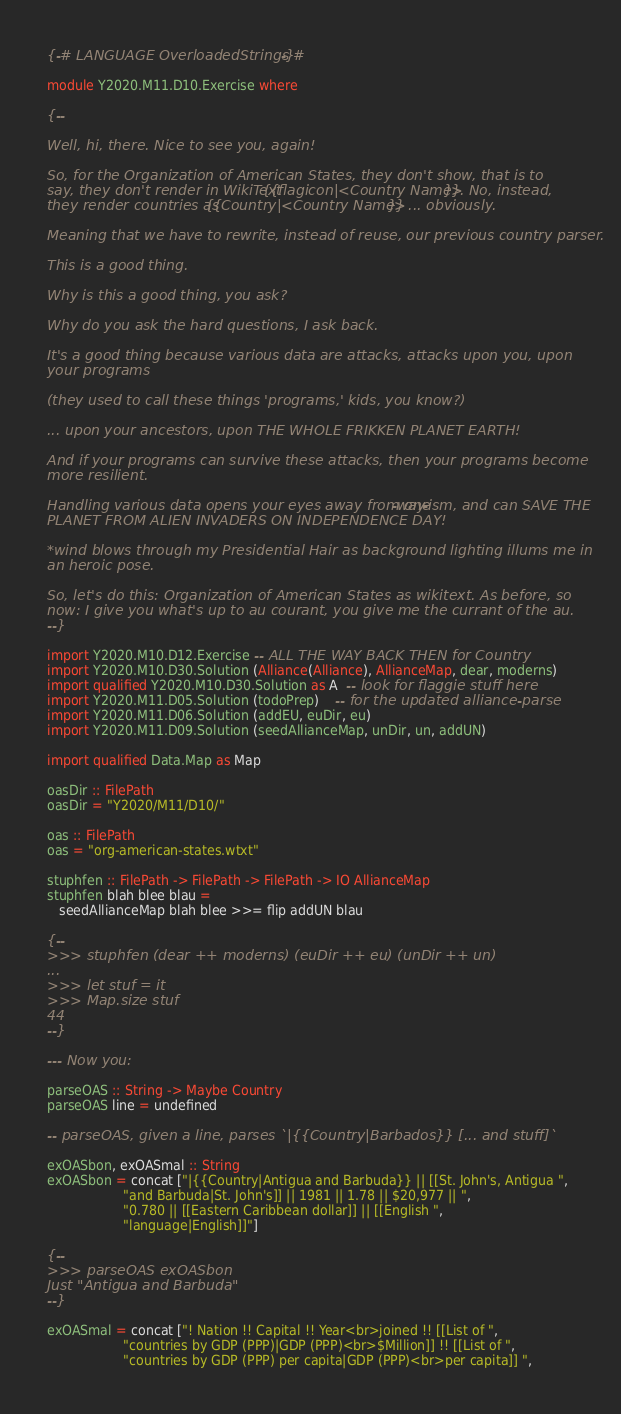Convert code to text. <code><loc_0><loc_0><loc_500><loc_500><_Haskell_>{-# LANGUAGE OverloadedStrings #-}

module Y2020.M11.D10.Exercise where

{--

Well, hi, there. Nice to see you, again!

So, for the Organization of American States, they don't show, that is to
say, they don't render in WikiText {{flagicon|<Country Name>}}. No, instead,
they render countries as {{Country|<Country Name>}} ... obviously.

Meaning that we have to rewrite, instead of reuse, our previous country parser.

This is a good thing.

Why is this a good thing, you ask?

Why do you ask the hard questions, I ask back.

It's a good thing because various data are attacks, attacks upon you, upon
your programs

(they used to call these things 'programs,' kids, you know?)

... upon your ancestors, upon THE WHOLE FRIKKEN PLANET EARTH!

And if your programs can survive these attacks, then your programs become
more resilient.

Handling various data opens your eyes away from one-way-ism, and can SAVE THE
PLANET FROM ALIEN INVADERS ON INDEPENDENCE DAY!

*wind blows through my Presidential Hair as background lighting illums me in
an heroic pose.

So, let's do this: Organization of American States as wikitext. As before, so
now: I give you what's up to au courant, you give me the currant of the au.
--}

import Y2020.M10.D12.Exercise -- ALL THE WAY BACK THEN for Country
import Y2020.M10.D30.Solution (Alliance(Alliance), AllianceMap, dear, moderns)
import qualified Y2020.M10.D30.Solution as A  -- look for flaggie stuff here
import Y2020.M11.D05.Solution (todoPrep)    -- for the updated alliance-parse
import Y2020.M11.D06.Solution (addEU, euDir, eu)
import Y2020.M11.D09.Solution (seedAllianceMap, unDir, un, addUN)

import qualified Data.Map as Map

oasDir :: FilePath
oasDir = "Y2020/M11/D10/"

oas :: FilePath
oas = "org-american-states.wtxt"

stuphfen :: FilePath -> FilePath -> FilePath -> IO AllianceMap
stuphfen blah blee blau =
   seedAllianceMap blah blee >>= flip addUN blau

{--
>>> stuphfen (dear ++ moderns) (euDir ++ eu) (unDir ++ un)
...
>>> let stuf = it
>>> Map.size stuf
44
--}

--- Now you:

parseOAS :: String -> Maybe Country
parseOAS line = undefined

-- parseOAS, given a line, parses `|{{Country|Barbados}} [... and stuff]`

exOASbon, exOASmal :: String
exOASbon = concat ["|{{Country|Antigua and Barbuda}} || [[St. John's, Antigua ",
                   "and Barbuda|St. John's]] || 1981 || 1.78 || $20,977 || ",
                   "0.780 || [[Eastern Caribbean dollar]] || [[English ",
                   "language|English]]"]

{--
>>> parseOAS exOASbon
Just "Antigua and Barbuda"
--}

exOASmal = concat ["! Nation !! Capital !! Year<br>joined !! [[List of ",
                   "countries by GDP (PPP)|GDP (PPP)<br>$Million]] !! [[List of ",
                   "countries by GDP (PPP) per capita|GDP (PPP)<br>per capita]] ",</code> 